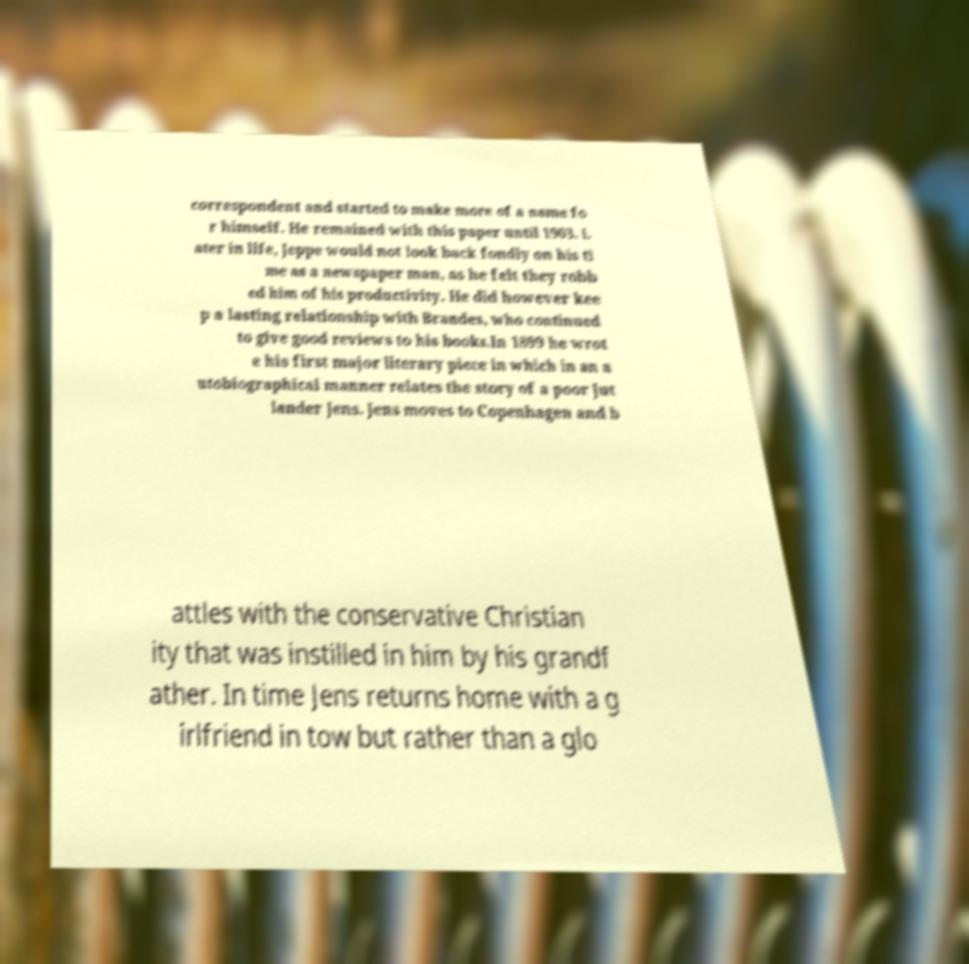For documentation purposes, I need the text within this image transcribed. Could you provide that? correspondent and started to make more of a name fo r himself. He remained with this paper until 1903. L ater in life, Jeppe would not look back fondly on his ti me as a newspaper man, as he felt they robb ed him of his productivity. He did however kee p a lasting relationship with Brandes, who continued to give good reviews to his books.In 1899 he wrot e his first major literary piece in which in an a utobiographical manner relates the story of a poor Jut lander Jens. Jens moves to Copenhagen and b attles with the conservative Christian ity that was instilled in him by his grandf ather. In time Jens returns home with a g irlfriend in tow but rather than a glo 